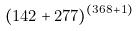Convert formula to latex. <formula><loc_0><loc_0><loc_500><loc_500>( 1 4 2 + 2 7 7 ) ^ { ( 3 6 8 + 1 ) }</formula> 